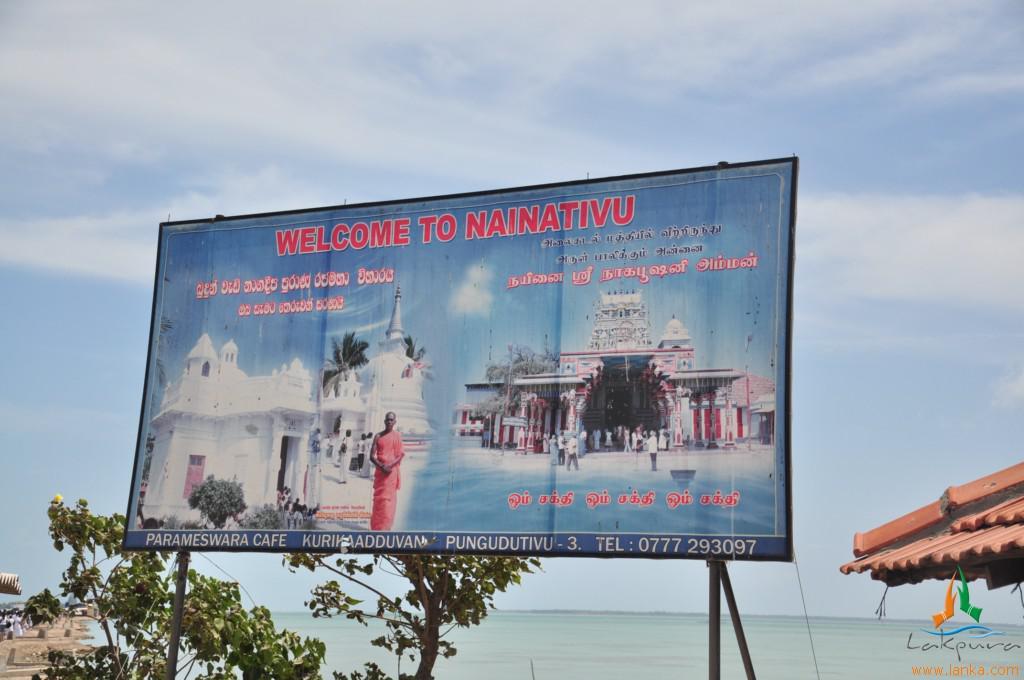What is the phone number on the advertisement?
Make the answer very short. 0777 293097. 